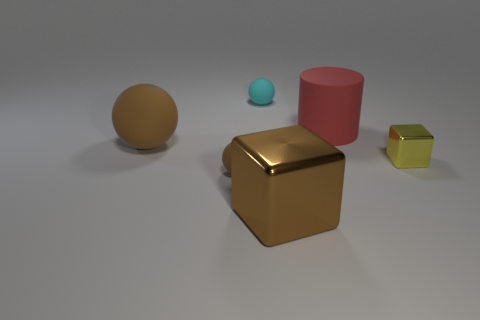Add 6 cyan balls. How many cyan balls exist? 7 Add 1 tiny balls. How many objects exist? 7 Subtract all brown blocks. How many blocks are left? 1 Subtract all tiny brown matte spheres. How many spheres are left? 2 Subtract 0 cyan cylinders. How many objects are left? 6 Subtract all cubes. How many objects are left? 4 Subtract 1 spheres. How many spheres are left? 2 Subtract all blue spheres. Subtract all cyan blocks. How many spheres are left? 3 Subtract all red spheres. How many yellow blocks are left? 1 Subtract all cylinders. Subtract all tiny blocks. How many objects are left? 4 